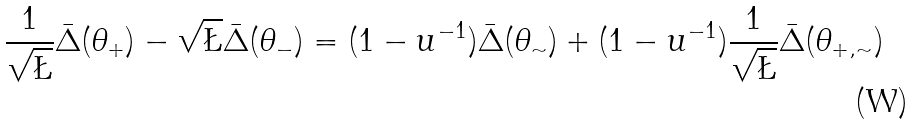Convert formula to latex. <formula><loc_0><loc_0><loc_500><loc_500>\frac { 1 } { \sqrt { \L } } \bar { \Delta } ( \theta _ { + } ) - \sqrt { \L } \bar { \Delta } ( \theta _ { - } ) = ( 1 - u ^ { - 1 } ) \bar { \Delta } ( \theta _ { \sim } ) + ( 1 - u ^ { - 1 } ) \frac { 1 } { \sqrt { \L } } \bar { \Delta } ( \theta _ { + , \sim } )</formula> 